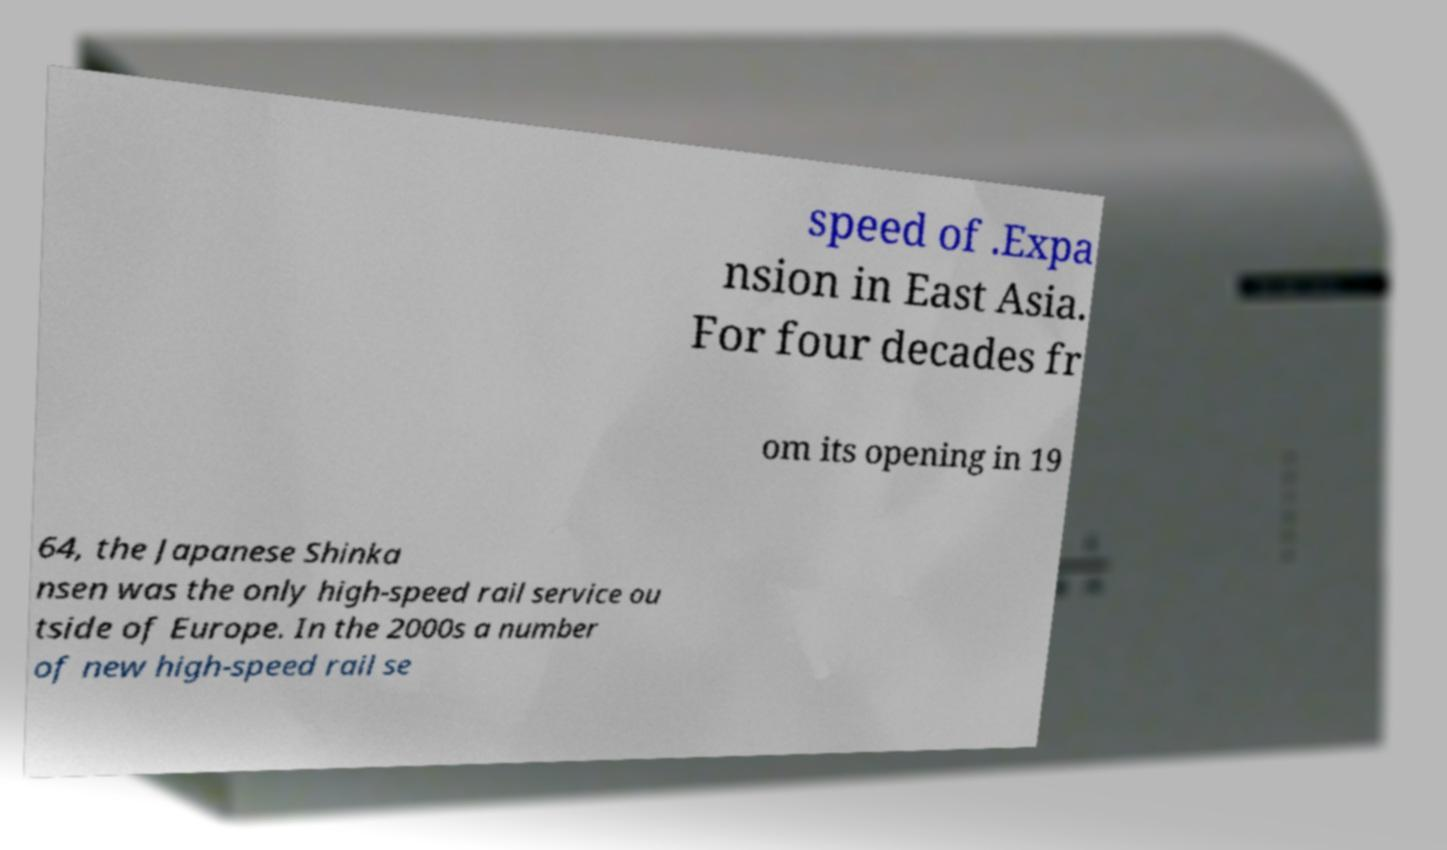Can you read and provide the text displayed in the image?This photo seems to have some interesting text. Can you extract and type it out for me? speed of .Expa nsion in East Asia. For four decades fr om its opening in 19 64, the Japanese Shinka nsen was the only high-speed rail service ou tside of Europe. In the 2000s a number of new high-speed rail se 